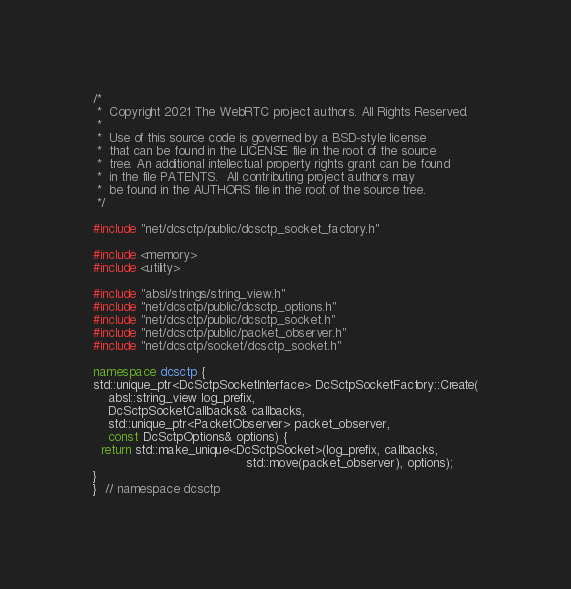Convert code to text. <code><loc_0><loc_0><loc_500><loc_500><_C++_>/*
 *  Copyright 2021 The WebRTC project authors. All Rights Reserved.
 *
 *  Use of this source code is governed by a BSD-style license
 *  that can be found in the LICENSE file in the root of the source
 *  tree. An additional intellectual property rights grant can be found
 *  in the file PATENTS.  All contributing project authors may
 *  be found in the AUTHORS file in the root of the source tree.
 */

#include "net/dcsctp/public/dcsctp_socket_factory.h"

#include <memory>
#include <utility>

#include "absl/strings/string_view.h"
#include "net/dcsctp/public/dcsctp_options.h"
#include "net/dcsctp/public/dcsctp_socket.h"
#include "net/dcsctp/public/packet_observer.h"
#include "net/dcsctp/socket/dcsctp_socket.h"

namespace dcsctp {
std::unique_ptr<DcSctpSocketInterface> DcSctpSocketFactory::Create(
    absl::string_view log_prefix,
    DcSctpSocketCallbacks& callbacks,
    std::unique_ptr<PacketObserver> packet_observer,
    const DcSctpOptions& options) {
  return std::make_unique<DcSctpSocket>(log_prefix, callbacks,
                                        std::move(packet_observer), options);
}
}  // namespace dcsctp
</code> 